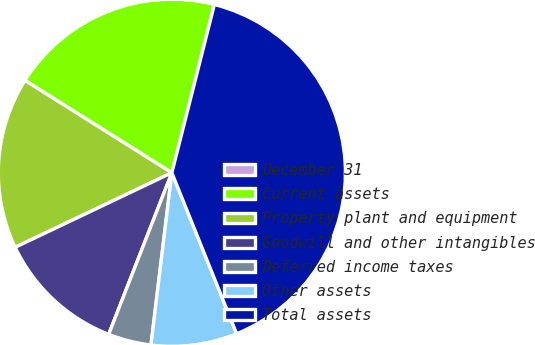Convert chart. <chart><loc_0><loc_0><loc_500><loc_500><pie_chart><fcel>December 31<fcel>Current assets<fcel>Property plant and equipment<fcel>Goodwill and other intangibles<fcel>Deferred income taxes<fcel>Other assets<fcel>Total assets<nl><fcel>0.02%<fcel>19.99%<fcel>16.0%<fcel>12.0%<fcel>4.01%<fcel>8.01%<fcel>39.97%<nl></chart> 